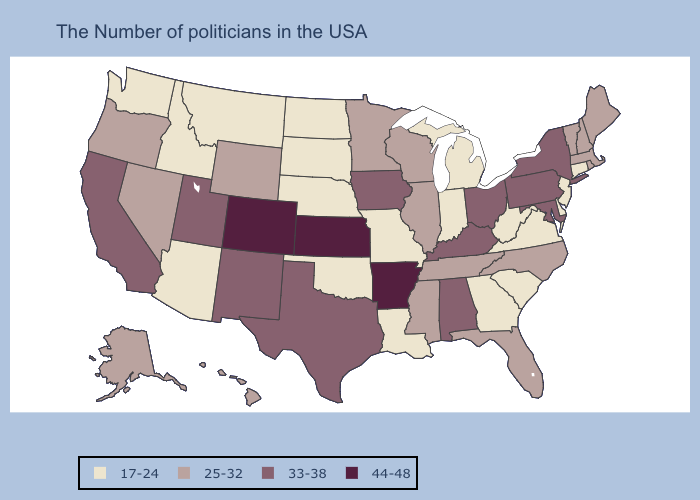What is the highest value in the Northeast ?
Keep it brief. 33-38. What is the highest value in the West ?
Concise answer only. 44-48. Does Illinois have the highest value in the USA?
Be succinct. No. What is the highest value in the Northeast ?
Concise answer only. 33-38. Among the states that border North Dakota , does Montana have the lowest value?
Be succinct. Yes. Does the first symbol in the legend represent the smallest category?
Answer briefly. Yes. Name the states that have a value in the range 17-24?
Answer briefly. Connecticut, New Jersey, Delaware, Virginia, South Carolina, West Virginia, Georgia, Michigan, Indiana, Louisiana, Missouri, Nebraska, Oklahoma, South Dakota, North Dakota, Montana, Arizona, Idaho, Washington. What is the lowest value in the Northeast?
Short answer required. 17-24. What is the value of New Hampshire?
Answer briefly. 25-32. Name the states that have a value in the range 44-48?
Answer briefly. Arkansas, Kansas, Colorado. What is the value of Idaho?
Concise answer only. 17-24. Name the states that have a value in the range 44-48?
Keep it brief. Arkansas, Kansas, Colorado. What is the value of Texas?
Quick response, please. 33-38. Does Illinois have the highest value in the USA?
Short answer required. No. Among the states that border Massachusetts , which have the lowest value?
Give a very brief answer. Connecticut. 